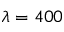Convert formula to latex. <formula><loc_0><loc_0><loc_500><loc_500>\lambda = 4 0 0</formula> 